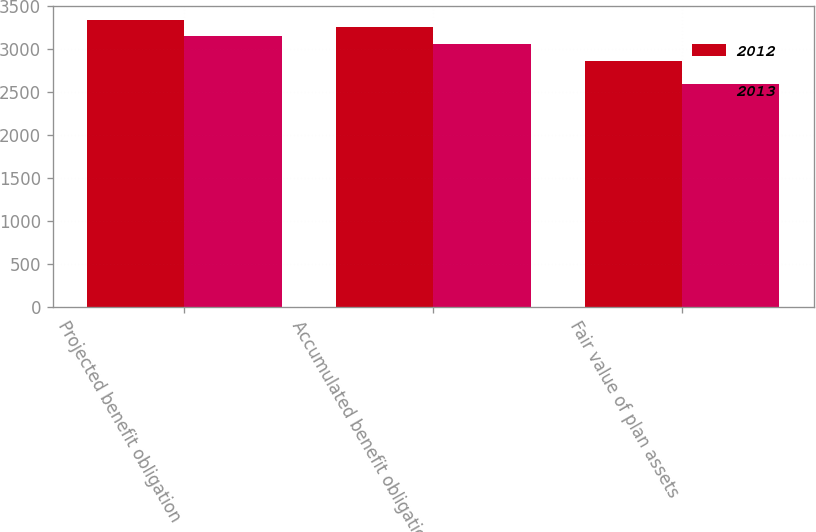Convert chart to OTSL. <chart><loc_0><loc_0><loc_500><loc_500><stacked_bar_chart><ecel><fcel>Projected benefit obligation<fcel>Accumulated benefit obligation<fcel>Fair value of plan assets<nl><fcel>2012<fcel>3338.8<fcel>3260.7<fcel>2863.3<nl><fcel>2013<fcel>3159.7<fcel>3057.2<fcel>2594.1<nl></chart> 